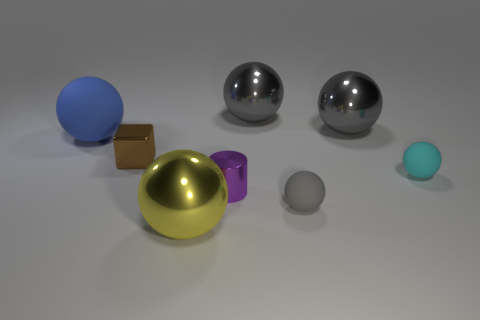There is a matte ball that is behind the tiny shiny thing that is behind the small cyan sphere; is there a small cyan ball that is behind it?
Keep it short and to the point. No. There is a tiny metal thing in front of the small metal cube; is it the same color as the large matte thing?
Your answer should be compact. No. How many spheres are small metallic things or big gray objects?
Provide a succinct answer. 2. What shape is the rubber thing on the right side of the tiny rubber sphere that is in front of the small purple cylinder?
Provide a short and direct response. Sphere. How big is the rubber object to the left of the big shiny thing in front of the rubber ball that is left of the purple cylinder?
Offer a very short reply. Large. Do the purple metallic cylinder and the gray matte sphere have the same size?
Provide a short and direct response. Yes. What number of things are gray metal objects or large objects?
Make the answer very short. 4. What is the size of the cylinder right of the rubber sphere left of the metallic cube?
Offer a terse response. Small. What size is the cube?
Your answer should be very brief. Small. What shape is the metal object that is behind the cyan rubber ball and in front of the blue matte ball?
Ensure brevity in your answer.  Cube. 